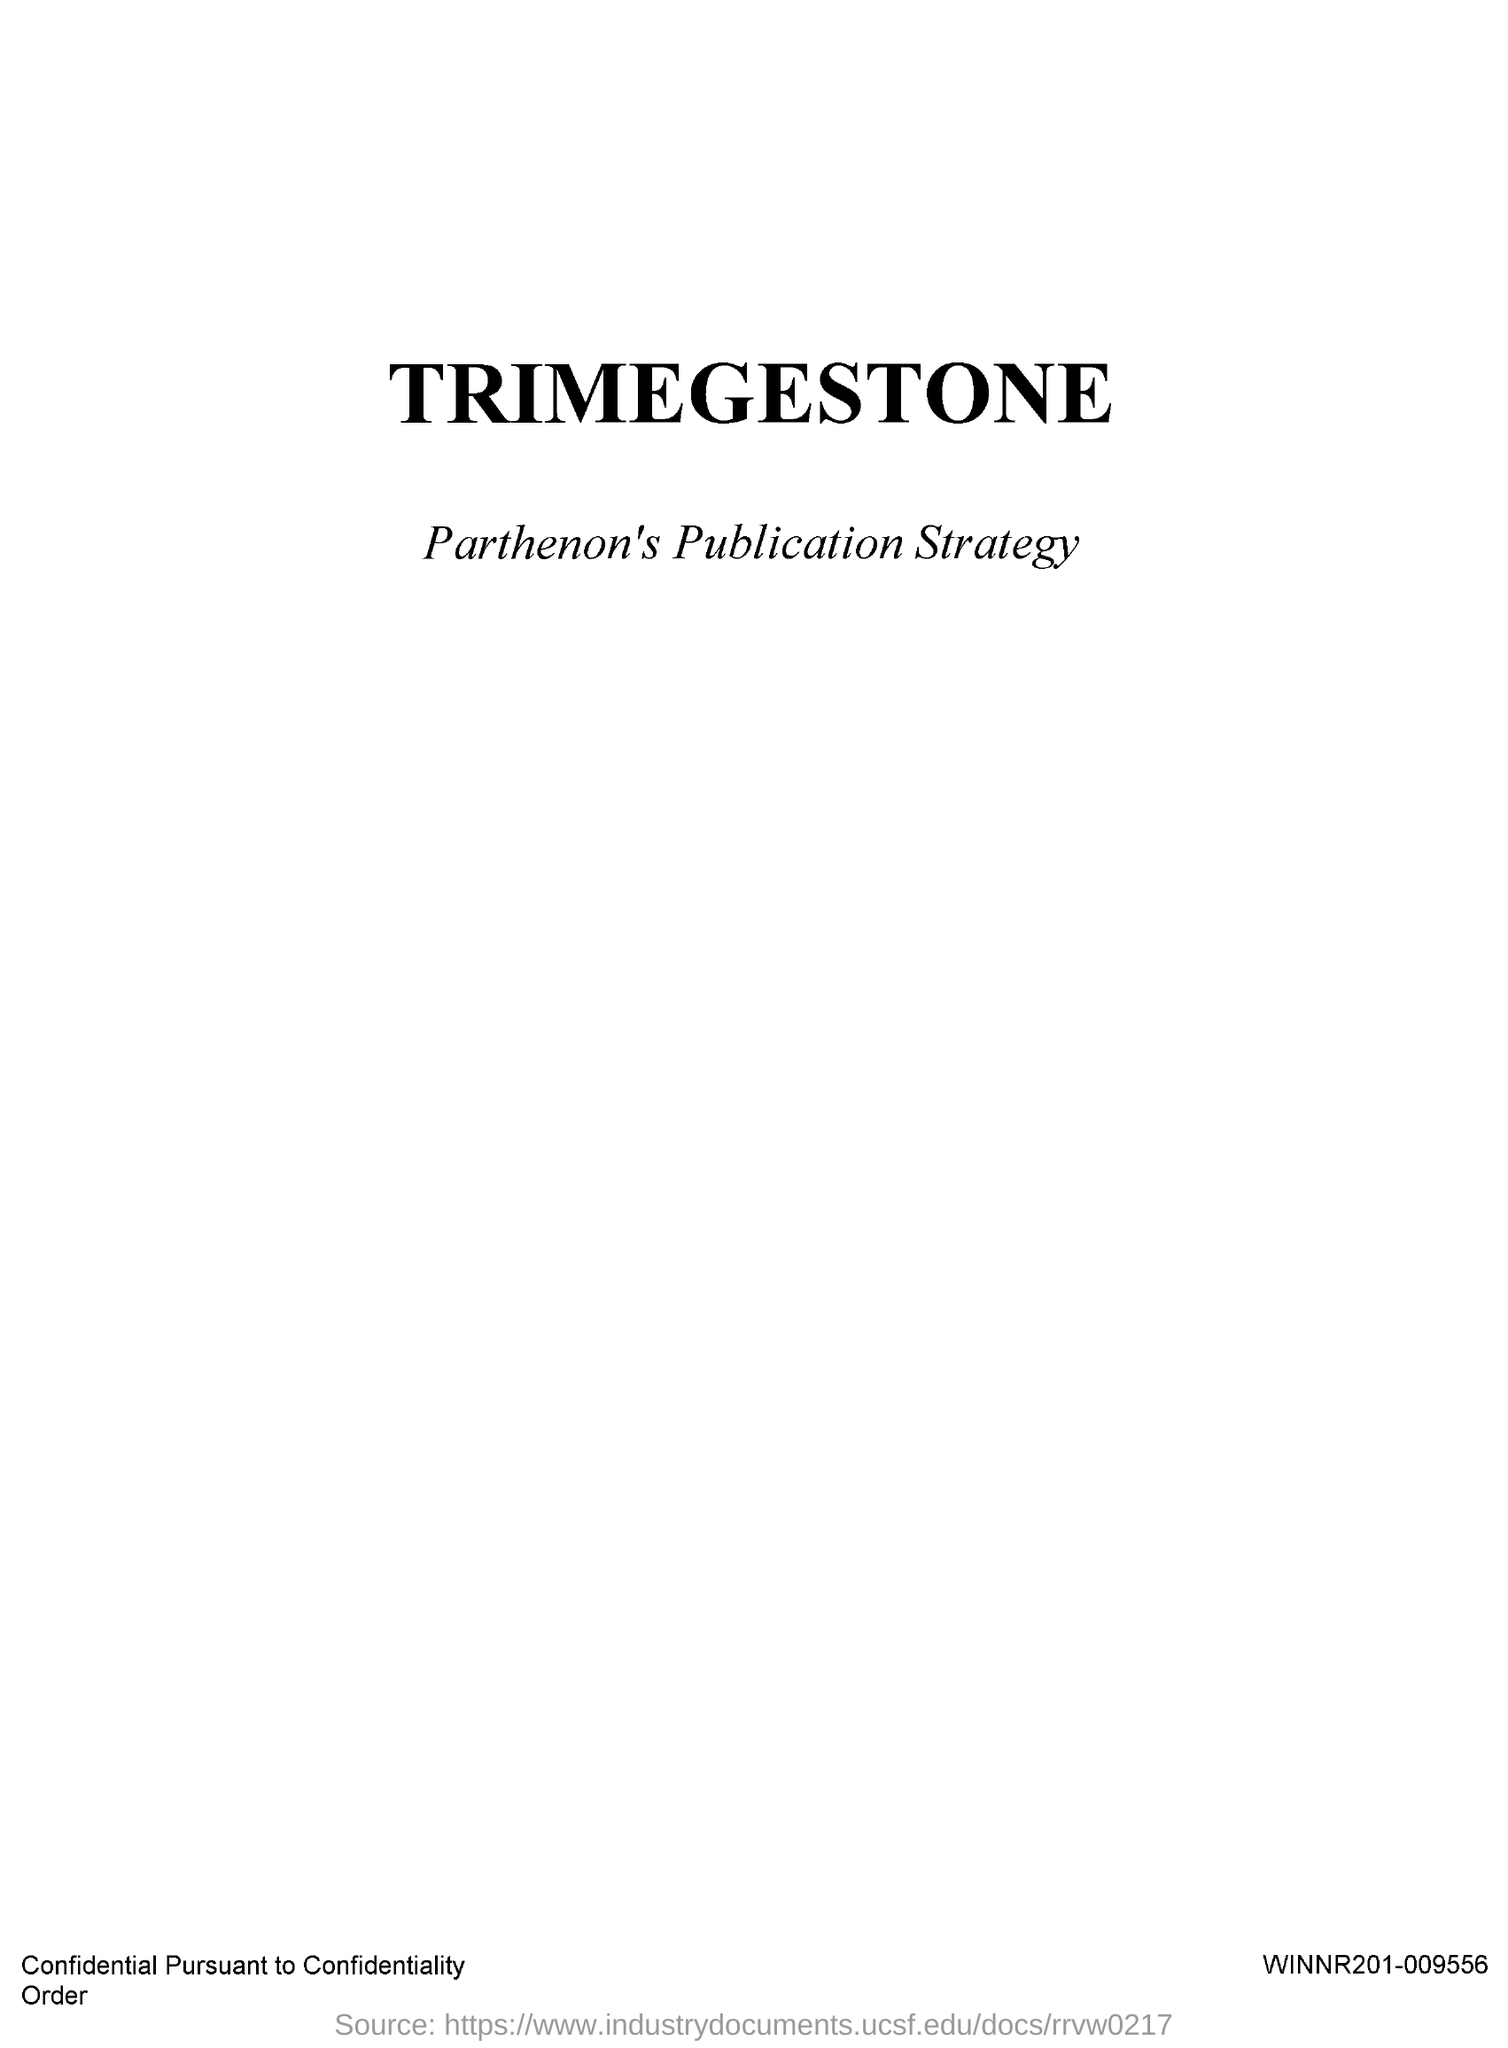Which drug is mentioned?
Offer a terse response. TRIMEGESTONE. 